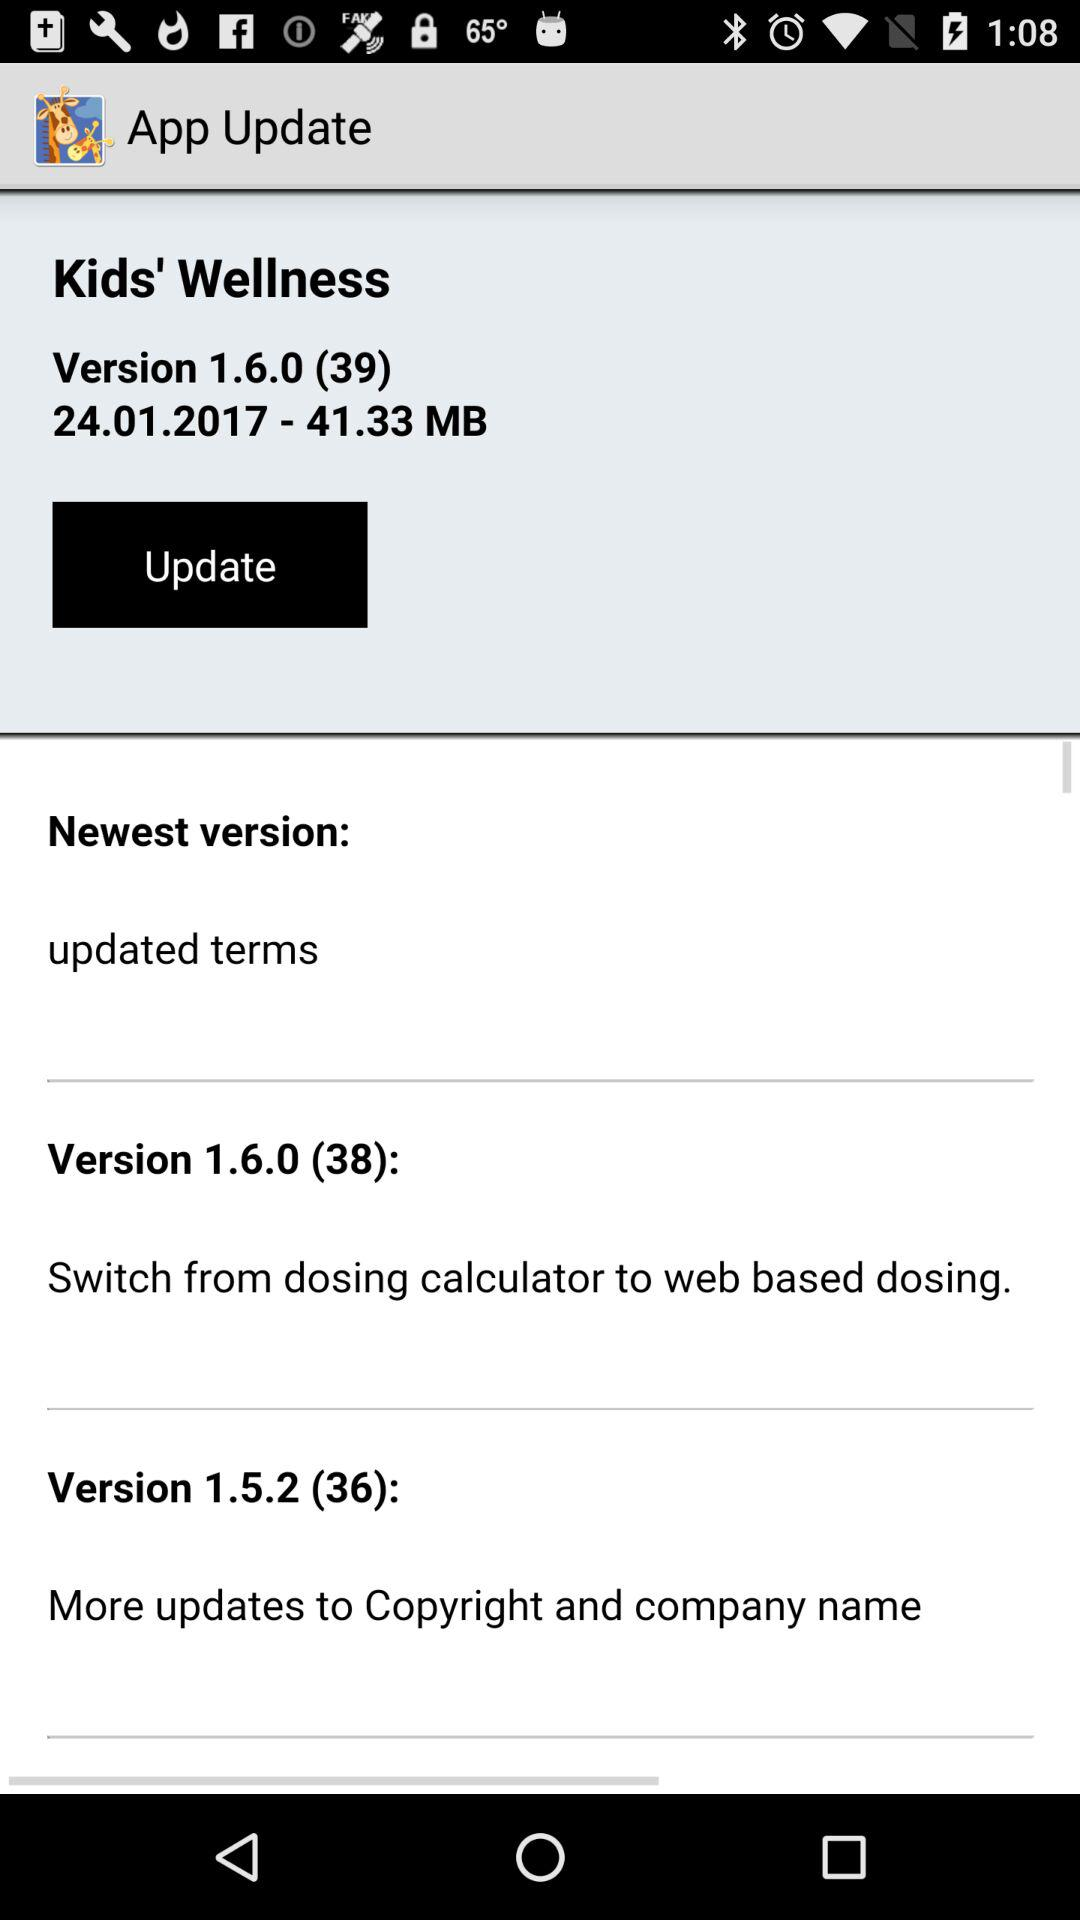What is the size of the "Kids' Wellness" app? The size of the "Kids' Wellness" app is 41.33 MB. 